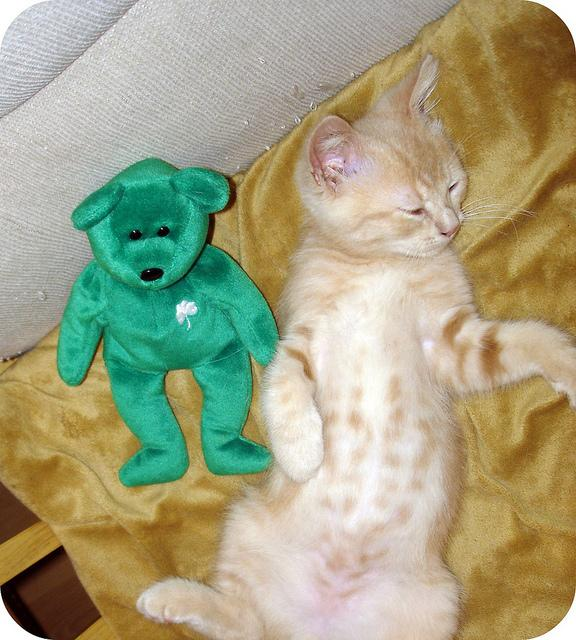What is the logo on the bear?

Choices:
A) maple
B) cotton
C) ball
D) shamrock shamrock 